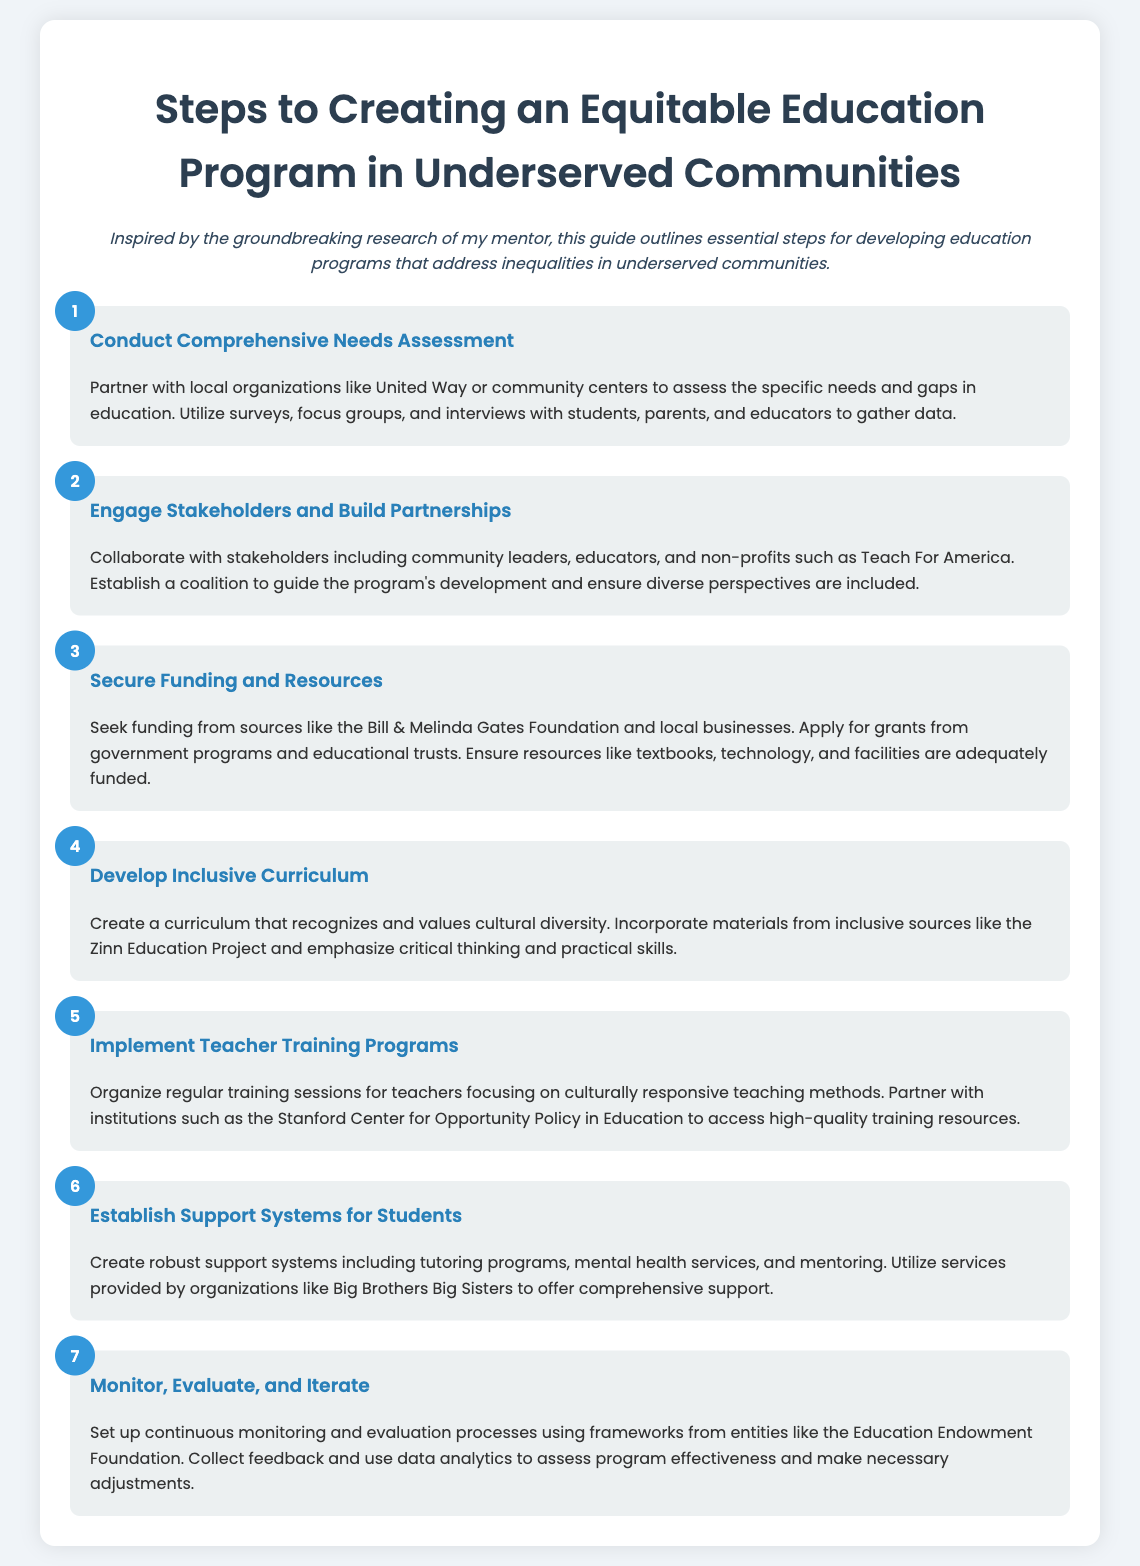What is the first step in creating an equitable education program? The first step outlined in the document is to conduct a comprehensive needs assessment.
Answer: Conduct Comprehensive Needs Assessment Who should be engaged to build partnerships? The document states that community leaders, educators, and non-profits should be engaged to build partnerships.
Answer: Community leaders, educators, and non-profits What is the goal of securing funding? The funding is needed to ensure resources like textbooks, technology, and facilities are adequately funded.
Answer: Ensure resources are adequately funded Which foundation is mentioned for seeking funding? The Bill & Melinda Gates Foundation is specifically mentioned as a source of funding.
Answer: Bill & Melinda Gates Foundation What type of training should teachers receive? Teachers should receive training focusing on culturally responsive teaching methods.
Answer: Culturally responsive teaching methods What is an example of a support system for students? The document suggests creating tutoring programs as an example of support systems for students.
Answer: Tutoring programs What is the final step in the process? The final step is to monitor, evaluate, and iterate on the program.
Answer: Monitor, evaluate, and iterate Which organization's frameworks are suggested for monitoring? The Education Endowment Foundation is mentioned as a source for monitoring frameworks.
Answer: Education Endowment Foundation 